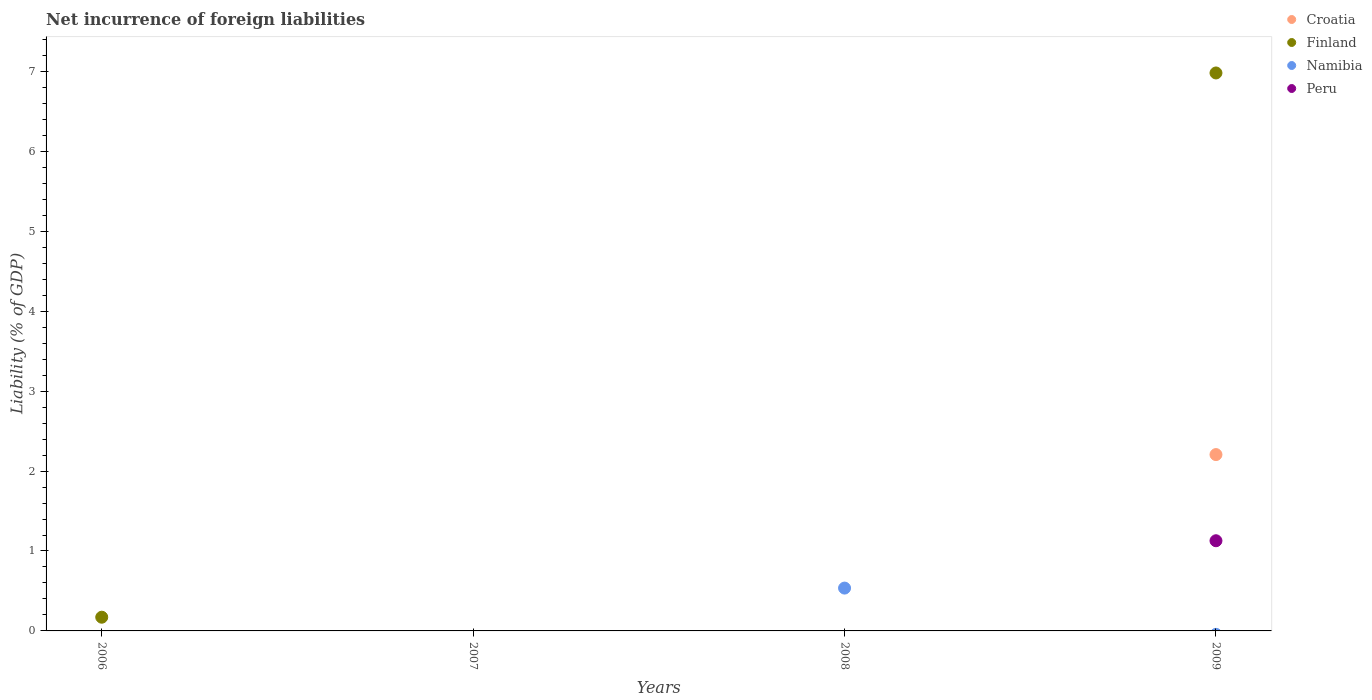How many different coloured dotlines are there?
Make the answer very short. 4. Is the number of dotlines equal to the number of legend labels?
Your answer should be very brief. No. Across all years, what is the maximum net incurrence of foreign liabilities in Namibia?
Make the answer very short. 0.54. Across all years, what is the minimum net incurrence of foreign liabilities in Finland?
Keep it short and to the point. 0. What is the total net incurrence of foreign liabilities in Finland in the graph?
Give a very brief answer. 7.15. What is the difference between the net incurrence of foreign liabilities in Finland in 2006 and that in 2009?
Ensure brevity in your answer.  -6.81. What is the difference between the net incurrence of foreign liabilities in Croatia in 2008 and the net incurrence of foreign liabilities in Finland in 2009?
Your answer should be very brief. -6.98. What is the average net incurrence of foreign liabilities in Finland per year?
Your answer should be very brief. 1.79. What is the difference between the highest and the lowest net incurrence of foreign liabilities in Croatia?
Give a very brief answer. 2.21. In how many years, is the net incurrence of foreign liabilities in Croatia greater than the average net incurrence of foreign liabilities in Croatia taken over all years?
Offer a terse response. 1. Is it the case that in every year, the sum of the net incurrence of foreign liabilities in Croatia and net incurrence of foreign liabilities in Peru  is greater than the sum of net incurrence of foreign liabilities in Namibia and net incurrence of foreign liabilities in Finland?
Offer a very short reply. No. Is the net incurrence of foreign liabilities in Finland strictly less than the net incurrence of foreign liabilities in Namibia over the years?
Offer a very short reply. No. What is the difference between two consecutive major ticks on the Y-axis?
Offer a terse response. 1. How many legend labels are there?
Ensure brevity in your answer.  4. How are the legend labels stacked?
Offer a very short reply. Vertical. What is the title of the graph?
Give a very brief answer. Net incurrence of foreign liabilities. What is the label or title of the Y-axis?
Offer a terse response. Liability (% of GDP). What is the Liability (% of GDP) in Croatia in 2006?
Make the answer very short. 0. What is the Liability (% of GDP) in Finland in 2006?
Your answer should be very brief. 0.17. What is the Liability (% of GDP) in Namibia in 2006?
Offer a terse response. 0. What is the Liability (% of GDP) of Peru in 2006?
Provide a short and direct response. 0. What is the Liability (% of GDP) in Croatia in 2008?
Keep it short and to the point. 0. What is the Liability (% of GDP) of Finland in 2008?
Provide a succinct answer. 0. What is the Liability (% of GDP) in Namibia in 2008?
Ensure brevity in your answer.  0.54. What is the Liability (% of GDP) in Peru in 2008?
Make the answer very short. 0. What is the Liability (% of GDP) in Croatia in 2009?
Offer a terse response. 2.21. What is the Liability (% of GDP) in Finland in 2009?
Keep it short and to the point. 6.98. What is the Liability (% of GDP) of Peru in 2009?
Provide a succinct answer. 1.13. Across all years, what is the maximum Liability (% of GDP) in Croatia?
Provide a succinct answer. 2.21. Across all years, what is the maximum Liability (% of GDP) in Finland?
Offer a terse response. 6.98. Across all years, what is the maximum Liability (% of GDP) in Namibia?
Your answer should be compact. 0.54. Across all years, what is the maximum Liability (% of GDP) in Peru?
Offer a very short reply. 1.13. What is the total Liability (% of GDP) in Croatia in the graph?
Provide a short and direct response. 2.21. What is the total Liability (% of GDP) in Finland in the graph?
Provide a short and direct response. 7.15. What is the total Liability (% of GDP) of Namibia in the graph?
Ensure brevity in your answer.  0.54. What is the total Liability (% of GDP) of Peru in the graph?
Your response must be concise. 1.13. What is the difference between the Liability (% of GDP) of Finland in 2006 and that in 2009?
Offer a terse response. -6.81. What is the difference between the Liability (% of GDP) of Finland in 2006 and the Liability (% of GDP) of Namibia in 2008?
Provide a succinct answer. -0.36. What is the difference between the Liability (% of GDP) in Finland in 2006 and the Liability (% of GDP) in Peru in 2009?
Provide a succinct answer. -0.96. What is the difference between the Liability (% of GDP) in Namibia in 2008 and the Liability (% of GDP) in Peru in 2009?
Your answer should be very brief. -0.59. What is the average Liability (% of GDP) in Croatia per year?
Keep it short and to the point. 0.55. What is the average Liability (% of GDP) of Finland per year?
Ensure brevity in your answer.  1.79. What is the average Liability (% of GDP) in Namibia per year?
Keep it short and to the point. 0.13. What is the average Liability (% of GDP) in Peru per year?
Make the answer very short. 0.28. In the year 2009, what is the difference between the Liability (% of GDP) of Croatia and Liability (% of GDP) of Finland?
Your response must be concise. -4.77. In the year 2009, what is the difference between the Liability (% of GDP) of Croatia and Liability (% of GDP) of Peru?
Give a very brief answer. 1.08. In the year 2009, what is the difference between the Liability (% of GDP) of Finland and Liability (% of GDP) of Peru?
Give a very brief answer. 5.85. What is the ratio of the Liability (% of GDP) in Finland in 2006 to that in 2009?
Offer a terse response. 0.02. What is the difference between the highest and the lowest Liability (% of GDP) of Croatia?
Keep it short and to the point. 2.21. What is the difference between the highest and the lowest Liability (% of GDP) of Finland?
Keep it short and to the point. 6.98. What is the difference between the highest and the lowest Liability (% of GDP) in Namibia?
Keep it short and to the point. 0.54. What is the difference between the highest and the lowest Liability (% of GDP) in Peru?
Your response must be concise. 1.13. 